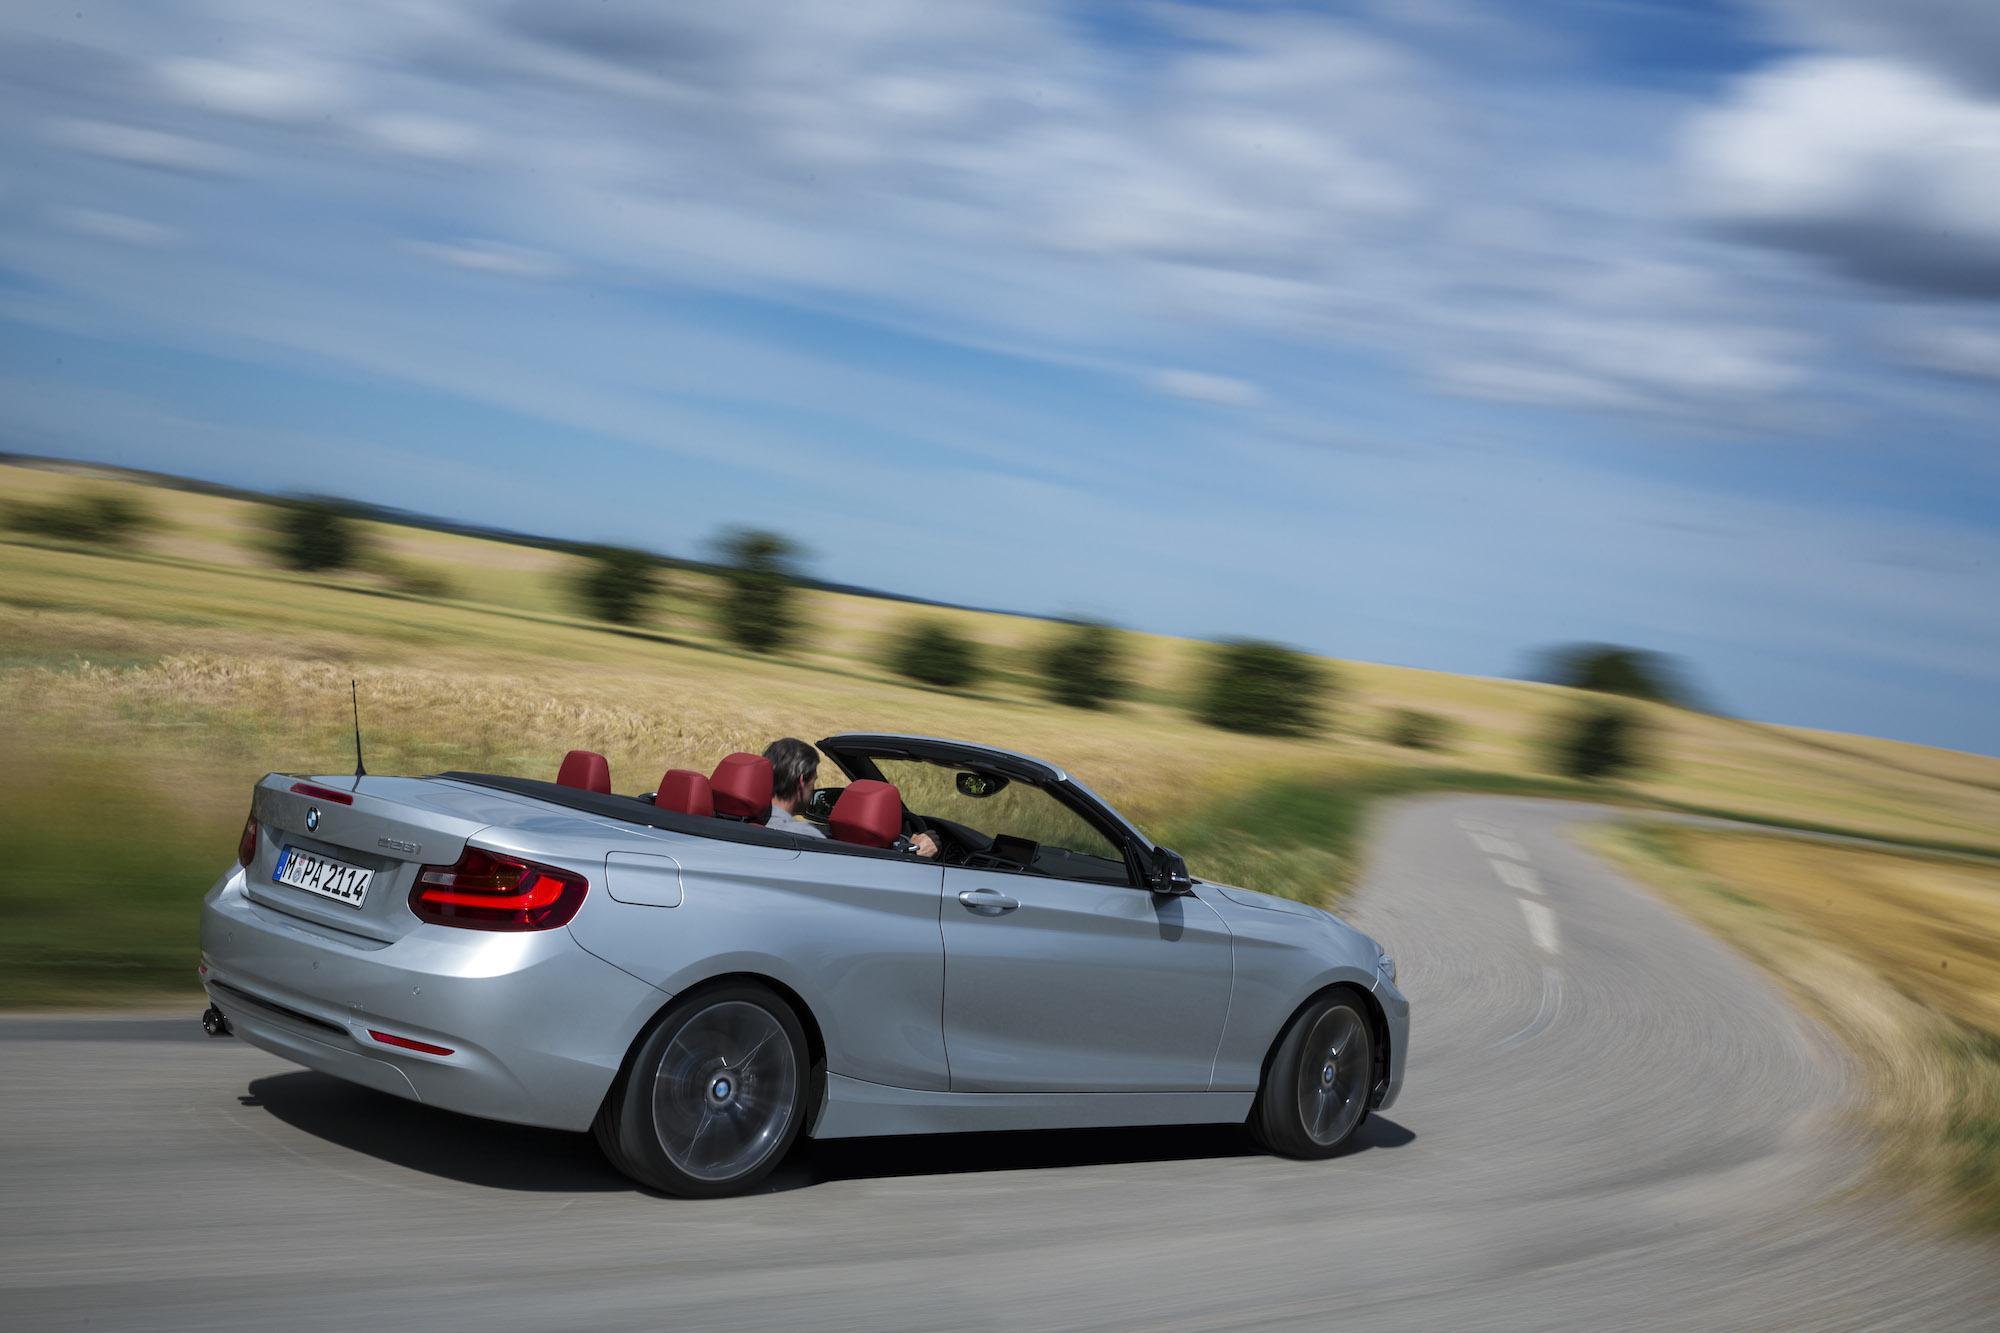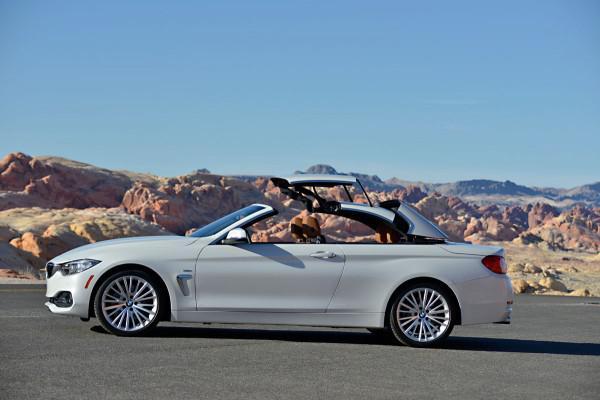The first image is the image on the left, the second image is the image on the right. Examine the images to the left and right. Is the description "Each image shows the entire length of a sports car with a convertible top that is in the act of being lowered." accurate? Answer yes or no. No. 